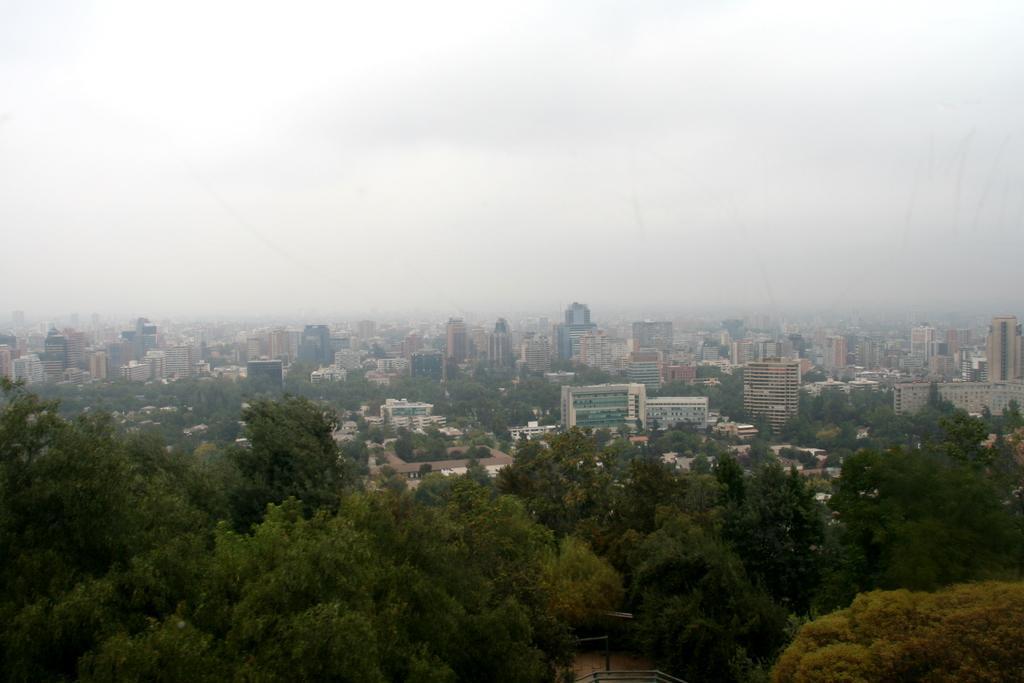How would you summarize this image in a sentence or two? In this picture we can see there are trees, buildings and fog. At the top of the image, there is the sky. At the bottom of the image, there is a railing. 